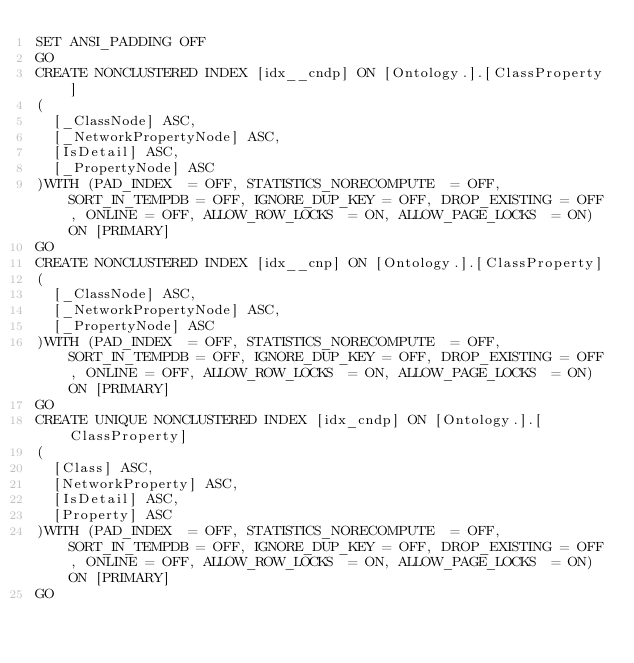Convert code to text. <code><loc_0><loc_0><loc_500><loc_500><_SQL_>SET ANSI_PADDING OFF
GO
CREATE NONCLUSTERED INDEX [idx__cndp] ON [Ontology.].[ClassProperty] 
(
	[_ClassNode] ASC,
	[_NetworkPropertyNode] ASC,
	[IsDetail] ASC,
	[_PropertyNode] ASC
)WITH (PAD_INDEX  = OFF, STATISTICS_NORECOMPUTE  = OFF, SORT_IN_TEMPDB = OFF, IGNORE_DUP_KEY = OFF, DROP_EXISTING = OFF, ONLINE = OFF, ALLOW_ROW_LOCKS  = ON, ALLOW_PAGE_LOCKS  = ON) ON [PRIMARY]
GO
CREATE NONCLUSTERED INDEX [idx__cnp] ON [Ontology.].[ClassProperty] 
(
	[_ClassNode] ASC,
	[_NetworkPropertyNode] ASC,
	[_PropertyNode] ASC
)WITH (PAD_INDEX  = OFF, STATISTICS_NORECOMPUTE  = OFF, SORT_IN_TEMPDB = OFF, IGNORE_DUP_KEY = OFF, DROP_EXISTING = OFF, ONLINE = OFF, ALLOW_ROW_LOCKS  = ON, ALLOW_PAGE_LOCKS  = ON) ON [PRIMARY]
GO
CREATE UNIQUE NONCLUSTERED INDEX [idx_cndp] ON [Ontology.].[ClassProperty] 
(
	[Class] ASC,
	[NetworkProperty] ASC,
	[IsDetail] ASC,
	[Property] ASC
)WITH (PAD_INDEX  = OFF, STATISTICS_NORECOMPUTE  = OFF, SORT_IN_TEMPDB = OFF, IGNORE_DUP_KEY = OFF, DROP_EXISTING = OFF, ONLINE = OFF, ALLOW_ROW_LOCKS  = ON, ALLOW_PAGE_LOCKS  = ON) ON [PRIMARY]
GO
</code> 